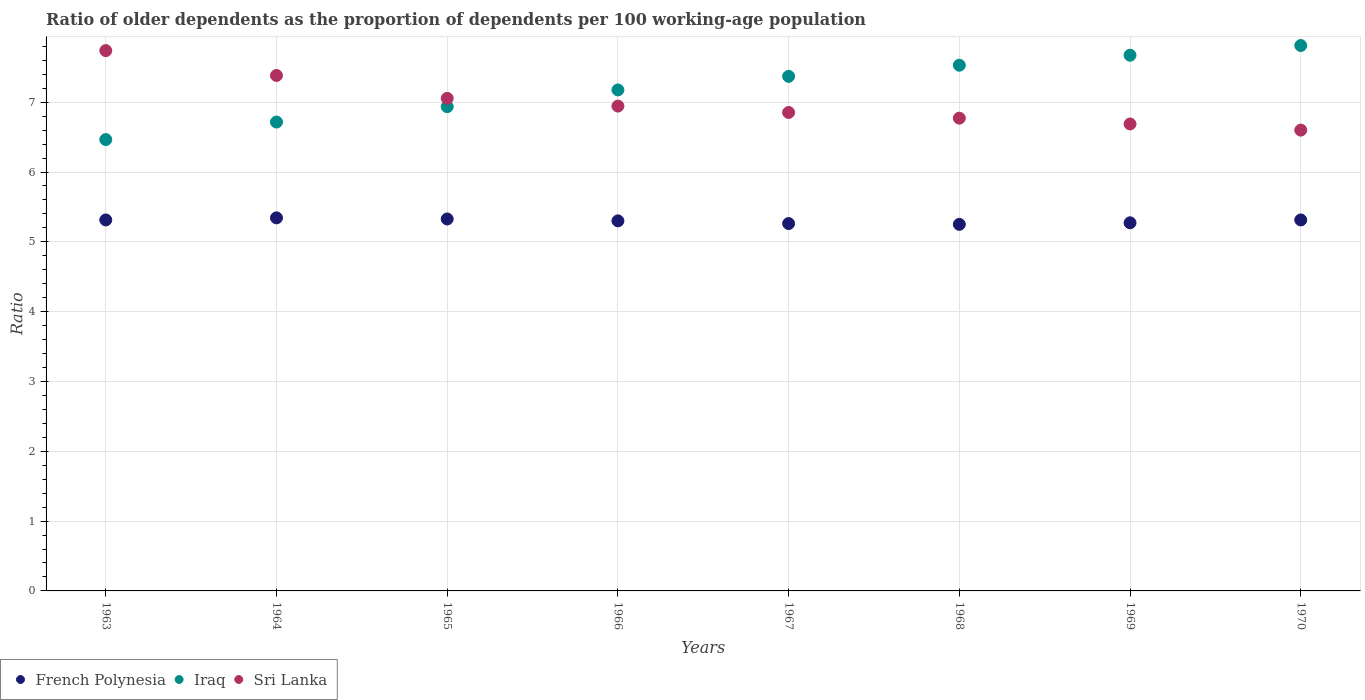Is the number of dotlines equal to the number of legend labels?
Offer a very short reply. Yes. What is the age dependency ratio(old) in Sri Lanka in 1970?
Ensure brevity in your answer.  6.6. Across all years, what is the maximum age dependency ratio(old) in Iraq?
Give a very brief answer. 7.81. Across all years, what is the minimum age dependency ratio(old) in Iraq?
Offer a very short reply. 6.46. In which year was the age dependency ratio(old) in Iraq maximum?
Your response must be concise. 1970. In which year was the age dependency ratio(old) in French Polynesia minimum?
Keep it short and to the point. 1968. What is the total age dependency ratio(old) in French Polynesia in the graph?
Your answer should be very brief. 42.38. What is the difference between the age dependency ratio(old) in French Polynesia in 1963 and that in 1964?
Your answer should be compact. -0.03. What is the difference between the age dependency ratio(old) in Iraq in 1967 and the age dependency ratio(old) in French Polynesia in 1964?
Provide a short and direct response. 2.03. What is the average age dependency ratio(old) in Iraq per year?
Your response must be concise. 7.21. In the year 1969, what is the difference between the age dependency ratio(old) in Sri Lanka and age dependency ratio(old) in Iraq?
Offer a very short reply. -0.98. In how many years, is the age dependency ratio(old) in Sri Lanka greater than 6.6?
Your response must be concise. 8. What is the ratio of the age dependency ratio(old) in Sri Lanka in 1963 to that in 1969?
Offer a very short reply. 1.16. Is the difference between the age dependency ratio(old) in Sri Lanka in 1963 and 1965 greater than the difference between the age dependency ratio(old) in Iraq in 1963 and 1965?
Ensure brevity in your answer.  Yes. What is the difference between the highest and the second highest age dependency ratio(old) in French Polynesia?
Give a very brief answer. 0.02. What is the difference between the highest and the lowest age dependency ratio(old) in Sri Lanka?
Give a very brief answer. 1.14. Is the age dependency ratio(old) in French Polynesia strictly greater than the age dependency ratio(old) in Sri Lanka over the years?
Provide a short and direct response. No. Is the age dependency ratio(old) in Sri Lanka strictly less than the age dependency ratio(old) in Iraq over the years?
Make the answer very short. No. Does the graph contain any zero values?
Your answer should be compact. No. Where does the legend appear in the graph?
Provide a short and direct response. Bottom left. How many legend labels are there?
Your answer should be compact. 3. What is the title of the graph?
Keep it short and to the point. Ratio of older dependents as the proportion of dependents per 100 working-age population. Does "Gambia, The" appear as one of the legend labels in the graph?
Keep it short and to the point. No. What is the label or title of the X-axis?
Ensure brevity in your answer.  Years. What is the label or title of the Y-axis?
Ensure brevity in your answer.  Ratio. What is the Ratio of French Polynesia in 1963?
Keep it short and to the point. 5.31. What is the Ratio in Iraq in 1963?
Offer a very short reply. 6.46. What is the Ratio in Sri Lanka in 1963?
Your response must be concise. 7.74. What is the Ratio in French Polynesia in 1964?
Offer a terse response. 5.34. What is the Ratio of Iraq in 1964?
Offer a terse response. 6.72. What is the Ratio of Sri Lanka in 1964?
Make the answer very short. 7.38. What is the Ratio in French Polynesia in 1965?
Provide a short and direct response. 5.33. What is the Ratio in Iraq in 1965?
Give a very brief answer. 6.94. What is the Ratio of Sri Lanka in 1965?
Provide a short and direct response. 7.05. What is the Ratio of French Polynesia in 1966?
Ensure brevity in your answer.  5.3. What is the Ratio in Iraq in 1966?
Your answer should be compact. 7.18. What is the Ratio of Sri Lanka in 1966?
Your answer should be compact. 6.94. What is the Ratio in French Polynesia in 1967?
Your response must be concise. 5.26. What is the Ratio in Iraq in 1967?
Your answer should be compact. 7.37. What is the Ratio in Sri Lanka in 1967?
Make the answer very short. 6.85. What is the Ratio in French Polynesia in 1968?
Give a very brief answer. 5.25. What is the Ratio in Iraq in 1968?
Keep it short and to the point. 7.53. What is the Ratio in Sri Lanka in 1968?
Give a very brief answer. 6.77. What is the Ratio of French Polynesia in 1969?
Offer a very short reply. 5.27. What is the Ratio of Iraq in 1969?
Make the answer very short. 7.67. What is the Ratio of Sri Lanka in 1969?
Your answer should be compact. 6.69. What is the Ratio in French Polynesia in 1970?
Ensure brevity in your answer.  5.31. What is the Ratio in Iraq in 1970?
Ensure brevity in your answer.  7.81. What is the Ratio of Sri Lanka in 1970?
Offer a terse response. 6.6. Across all years, what is the maximum Ratio of French Polynesia?
Your response must be concise. 5.34. Across all years, what is the maximum Ratio in Iraq?
Provide a short and direct response. 7.81. Across all years, what is the maximum Ratio in Sri Lanka?
Ensure brevity in your answer.  7.74. Across all years, what is the minimum Ratio in French Polynesia?
Provide a succinct answer. 5.25. Across all years, what is the minimum Ratio in Iraq?
Make the answer very short. 6.46. Across all years, what is the minimum Ratio of Sri Lanka?
Offer a very short reply. 6.6. What is the total Ratio in French Polynesia in the graph?
Offer a terse response. 42.38. What is the total Ratio in Iraq in the graph?
Your response must be concise. 57.68. What is the total Ratio in Sri Lanka in the graph?
Make the answer very short. 56.03. What is the difference between the Ratio in French Polynesia in 1963 and that in 1964?
Give a very brief answer. -0.03. What is the difference between the Ratio in Iraq in 1963 and that in 1964?
Your answer should be compact. -0.25. What is the difference between the Ratio in Sri Lanka in 1963 and that in 1964?
Offer a terse response. 0.36. What is the difference between the Ratio of French Polynesia in 1963 and that in 1965?
Provide a succinct answer. -0.01. What is the difference between the Ratio of Iraq in 1963 and that in 1965?
Ensure brevity in your answer.  -0.47. What is the difference between the Ratio in Sri Lanka in 1963 and that in 1965?
Offer a very short reply. 0.68. What is the difference between the Ratio in French Polynesia in 1963 and that in 1966?
Offer a very short reply. 0.01. What is the difference between the Ratio of Iraq in 1963 and that in 1966?
Provide a short and direct response. -0.71. What is the difference between the Ratio of Sri Lanka in 1963 and that in 1966?
Provide a succinct answer. 0.79. What is the difference between the Ratio in French Polynesia in 1963 and that in 1967?
Offer a terse response. 0.05. What is the difference between the Ratio in Iraq in 1963 and that in 1967?
Provide a short and direct response. -0.91. What is the difference between the Ratio of Sri Lanka in 1963 and that in 1967?
Your answer should be very brief. 0.89. What is the difference between the Ratio of French Polynesia in 1963 and that in 1968?
Ensure brevity in your answer.  0.06. What is the difference between the Ratio of Iraq in 1963 and that in 1968?
Make the answer very short. -1.07. What is the difference between the Ratio of Sri Lanka in 1963 and that in 1968?
Your response must be concise. 0.97. What is the difference between the Ratio of French Polynesia in 1963 and that in 1969?
Offer a terse response. 0.04. What is the difference between the Ratio in Iraq in 1963 and that in 1969?
Keep it short and to the point. -1.21. What is the difference between the Ratio in Sri Lanka in 1963 and that in 1969?
Your response must be concise. 1.05. What is the difference between the Ratio of Iraq in 1963 and that in 1970?
Offer a terse response. -1.35. What is the difference between the Ratio in Sri Lanka in 1963 and that in 1970?
Your answer should be very brief. 1.14. What is the difference between the Ratio of French Polynesia in 1964 and that in 1965?
Make the answer very short. 0.02. What is the difference between the Ratio in Iraq in 1964 and that in 1965?
Keep it short and to the point. -0.22. What is the difference between the Ratio of Sri Lanka in 1964 and that in 1965?
Keep it short and to the point. 0.33. What is the difference between the Ratio of French Polynesia in 1964 and that in 1966?
Your answer should be compact. 0.04. What is the difference between the Ratio in Iraq in 1964 and that in 1966?
Offer a very short reply. -0.46. What is the difference between the Ratio of Sri Lanka in 1964 and that in 1966?
Provide a succinct answer. 0.44. What is the difference between the Ratio in French Polynesia in 1964 and that in 1967?
Offer a terse response. 0.08. What is the difference between the Ratio of Iraq in 1964 and that in 1967?
Provide a short and direct response. -0.65. What is the difference between the Ratio in Sri Lanka in 1964 and that in 1967?
Your answer should be compact. 0.53. What is the difference between the Ratio in French Polynesia in 1964 and that in 1968?
Offer a very short reply. 0.09. What is the difference between the Ratio in Iraq in 1964 and that in 1968?
Your answer should be compact. -0.81. What is the difference between the Ratio of Sri Lanka in 1964 and that in 1968?
Offer a very short reply. 0.61. What is the difference between the Ratio of French Polynesia in 1964 and that in 1969?
Make the answer very short. 0.07. What is the difference between the Ratio of Iraq in 1964 and that in 1969?
Provide a succinct answer. -0.96. What is the difference between the Ratio in Sri Lanka in 1964 and that in 1969?
Offer a very short reply. 0.69. What is the difference between the Ratio in French Polynesia in 1964 and that in 1970?
Offer a terse response. 0.03. What is the difference between the Ratio in Iraq in 1964 and that in 1970?
Offer a very short reply. -1.1. What is the difference between the Ratio in Sri Lanka in 1964 and that in 1970?
Give a very brief answer. 0.78. What is the difference between the Ratio in French Polynesia in 1965 and that in 1966?
Provide a succinct answer. 0.03. What is the difference between the Ratio in Iraq in 1965 and that in 1966?
Provide a short and direct response. -0.24. What is the difference between the Ratio in Sri Lanka in 1965 and that in 1966?
Ensure brevity in your answer.  0.11. What is the difference between the Ratio of French Polynesia in 1965 and that in 1967?
Your answer should be very brief. 0.07. What is the difference between the Ratio of Iraq in 1965 and that in 1967?
Keep it short and to the point. -0.43. What is the difference between the Ratio in Sri Lanka in 1965 and that in 1967?
Make the answer very short. 0.2. What is the difference between the Ratio of French Polynesia in 1965 and that in 1968?
Ensure brevity in your answer.  0.08. What is the difference between the Ratio of Iraq in 1965 and that in 1968?
Keep it short and to the point. -0.59. What is the difference between the Ratio of Sri Lanka in 1965 and that in 1968?
Ensure brevity in your answer.  0.28. What is the difference between the Ratio in French Polynesia in 1965 and that in 1969?
Keep it short and to the point. 0.05. What is the difference between the Ratio of Iraq in 1965 and that in 1969?
Ensure brevity in your answer.  -0.74. What is the difference between the Ratio of Sri Lanka in 1965 and that in 1969?
Your answer should be compact. 0.37. What is the difference between the Ratio of French Polynesia in 1965 and that in 1970?
Provide a succinct answer. 0.01. What is the difference between the Ratio of Iraq in 1965 and that in 1970?
Offer a terse response. -0.88. What is the difference between the Ratio in Sri Lanka in 1965 and that in 1970?
Provide a succinct answer. 0.45. What is the difference between the Ratio in French Polynesia in 1966 and that in 1967?
Your answer should be compact. 0.04. What is the difference between the Ratio in Iraq in 1966 and that in 1967?
Ensure brevity in your answer.  -0.19. What is the difference between the Ratio in Sri Lanka in 1966 and that in 1967?
Your answer should be very brief. 0.09. What is the difference between the Ratio of French Polynesia in 1966 and that in 1968?
Your response must be concise. 0.05. What is the difference between the Ratio of Iraq in 1966 and that in 1968?
Offer a very short reply. -0.35. What is the difference between the Ratio in Sri Lanka in 1966 and that in 1968?
Offer a very short reply. 0.17. What is the difference between the Ratio of French Polynesia in 1966 and that in 1969?
Offer a terse response. 0.03. What is the difference between the Ratio of Iraq in 1966 and that in 1969?
Keep it short and to the point. -0.5. What is the difference between the Ratio of Sri Lanka in 1966 and that in 1969?
Your response must be concise. 0.26. What is the difference between the Ratio in French Polynesia in 1966 and that in 1970?
Offer a very short reply. -0.01. What is the difference between the Ratio of Iraq in 1966 and that in 1970?
Your response must be concise. -0.64. What is the difference between the Ratio of Sri Lanka in 1966 and that in 1970?
Offer a terse response. 0.34. What is the difference between the Ratio of French Polynesia in 1967 and that in 1968?
Your answer should be compact. 0.01. What is the difference between the Ratio of Iraq in 1967 and that in 1968?
Give a very brief answer. -0.16. What is the difference between the Ratio in Sri Lanka in 1967 and that in 1968?
Offer a very short reply. 0.08. What is the difference between the Ratio of French Polynesia in 1967 and that in 1969?
Make the answer very short. -0.01. What is the difference between the Ratio of Iraq in 1967 and that in 1969?
Provide a succinct answer. -0.3. What is the difference between the Ratio of Sri Lanka in 1967 and that in 1969?
Offer a terse response. 0.16. What is the difference between the Ratio in French Polynesia in 1967 and that in 1970?
Keep it short and to the point. -0.05. What is the difference between the Ratio of Iraq in 1967 and that in 1970?
Provide a short and direct response. -0.44. What is the difference between the Ratio in Sri Lanka in 1967 and that in 1970?
Your answer should be compact. 0.25. What is the difference between the Ratio in French Polynesia in 1968 and that in 1969?
Make the answer very short. -0.02. What is the difference between the Ratio of Iraq in 1968 and that in 1969?
Ensure brevity in your answer.  -0.14. What is the difference between the Ratio of Sri Lanka in 1968 and that in 1969?
Ensure brevity in your answer.  0.08. What is the difference between the Ratio of French Polynesia in 1968 and that in 1970?
Your answer should be very brief. -0.06. What is the difference between the Ratio of Iraq in 1968 and that in 1970?
Provide a succinct answer. -0.28. What is the difference between the Ratio in Sri Lanka in 1968 and that in 1970?
Ensure brevity in your answer.  0.17. What is the difference between the Ratio of French Polynesia in 1969 and that in 1970?
Offer a very short reply. -0.04. What is the difference between the Ratio in Iraq in 1969 and that in 1970?
Keep it short and to the point. -0.14. What is the difference between the Ratio in Sri Lanka in 1969 and that in 1970?
Make the answer very short. 0.09. What is the difference between the Ratio in French Polynesia in 1963 and the Ratio in Iraq in 1964?
Ensure brevity in your answer.  -1.4. What is the difference between the Ratio in French Polynesia in 1963 and the Ratio in Sri Lanka in 1964?
Offer a very short reply. -2.07. What is the difference between the Ratio of Iraq in 1963 and the Ratio of Sri Lanka in 1964?
Keep it short and to the point. -0.92. What is the difference between the Ratio of French Polynesia in 1963 and the Ratio of Iraq in 1965?
Offer a very short reply. -1.62. What is the difference between the Ratio of French Polynesia in 1963 and the Ratio of Sri Lanka in 1965?
Provide a short and direct response. -1.74. What is the difference between the Ratio of Iraq in 1963 and the Ratio of Sri Lanka in 1965?
Keep it short and to the point. -0.59. What is the difference between the Ratio of French Polynesia in 1963 and the Ratio of Iraq in 1966?
Keep it short and to the point. -1.86. What is the difference between the Ratio of French Polynesia in 1963 and the Ratio of Sri Lanka in 1966?
Provide a short and direct response. -1.63. What is the difference between the Ratio of Iraq in 1963 and the Ratio of Sri Lanka in 1966?
Your answer should be very brief. -0.48. What is the difference between the Ratio of French Polynesia in 1963 and the Ratio of Iraq in 1967?
Make the answer very short. -2.06. What is the difference between the Ratio of French Polynesia in 1963 and the Ratio of Sri Lanka in 1967?
Ensure brevity in your answer.  -1.54. What is the difference between the Ratio in Iraq in 1963 and the Ratio in Sri Lanka in 1967?
Ensure brevity in your answer.  -0.39. What is the difference between the Ratio in French Polynesia in 1963 and the Ratio in Iraq in 1968?
Offer a very short reply. -2.22. What is the difference between the Ratio of French Polynesia in 1963 and the Ratio of Sri Lanka in 1968?
Your answer should be very brief. -1.46. What is the difference between the Ratio of Iraq in 1963 and the Ratio of Sri Lanka in 1968?
Ensure brevity in your answer.  -0.31. What is the difference between the Ratio in French Polynesia in 1963 and the Ratio in Iraq in 1969?
Make the answer very short. -2.36. What is the difference between the Ratio of French Polynesia in 1963 and the Ratio of Sri Lanka in 1969?
Offer a very short reply. -1.37. What is the difference between the Ratio of Iraq in 1963 and the Ratio of Sri Lanka in 1969?
Offer a very short reply. -0.22. What is the difference between the Ratio in French Polynesia in 1963 and the Ratio in Iraq in 1970?
Provide a succinct answer. -2.5. What is the difference between the Ratio of French Polynesia in 1963 and the Ratio of Sri Lanka in 1970?
Ensure brevity in your answer.  -1.29. What is the difference between the Ratio in Iraq in 1963 and the Ratio in Sri Lanka in 1970?
Your answer should be compact. -0.14. What is the difference between the Ratio in French Polynesia in 1964 and the Ratio in Iraq in 1965?
Provide a short and direct response. -1.59. What is the difference between the Ratio of French Polynesia in 1964 and the Ratio of Sri Lanka in 1965?
Your response must be concise. -1.71. What is the difference between the Ratio in Iraq in 1964 and the Ratio in Sri Lanka in 1965?
Provide a short and direct response. -0.34. What is the difference between the Ratio in French Polynesia in 1964 and the Ratio in Iraq in 1966?
Ensure brevity in your answer.  -1.83. What is the difference between the Ratio in French Polynesia in 1964 and the Ratio in Sri Lanka in 1966?
Your answer should be compact. -1.6. What is the difference between the Ratio in Iraq in 1964 and the Ratio in Sri Lanka in 1966?
Your answer should be compact. -0.23. What is the difference between the Ratio in French Polynesia in 1964 and the Ratio in Iraq in 1967?
Keep it short and to the point. -2.03. What is the difference between the Ratio of French Polynesia in 1964 and the Ratio of Sri Lanka in 1967?
Provide a short and direct response. -1.51. What is the difference between the Ratio in Iraq in 1964 and the Ratio in Sri Lanka in 1967?
Offer a terse response. -0.14. What is the difference between the Ratio in French Polynesia in 1964 and the Ratio in Iraq in 1968?
Make the answer very short. -2.19. What is the difference between the Ratio in French Polynesia in 1964 and the Ratio in Sri Lanka in 1968?
Provide a succinct answer. -1.43. What is the difference between the Ratio of Iraq in 1964 and the Ratio of Sri Lanka in 1968?
Your answer should be compact. -0.06. What is the difference between the Ratio in French Polynesia in 1964 and the Ratio in Iraq in 1969?
Make the answer very short. -2.33. What is the difference between the Ratio of French Polynesia in 1964 and the Ratio of Sri Lanka in 1969?
Ensure brevity in your answer.  -1.34. What is the difference between the Ratio of Iraq in 1964 and the Ratio of Sri Lanka in 1969?
Your response must be concise. 0.03. What is the difference between the Ratio of French Polynesia in 1964 and the Ratio of Iraq in 1970?
Offer a very short reply. -2.47. What is the difference between the Ratio of French Polynesia in 1964 and the Ratio of Sri Lanka in 1970?
Make the answer very short. -1.26. What is the difference between the Ratio of Iraq in 1964 and the Ratio of Sri Lanka in 1970?
Keep it short and to the point. 0.12. What is the difference between the Ratio in French Polynesia in 1965 and the Ratio in Iraq in 1966?
Provide a short and direct response. -1.85. What is the difference between the Ratio in French Polynesia in 1965 and the Ratio in Sri Lanka in 1966?
Your answer should be very brief. -1.62. What is the difference between the Ratio of Iraq in 1965 and the Ratio of Sri Lanka in 1966?
Make the answer very short. -0.01. What is the difference between the Ratio of French Polynesia in 1965 and the Ratio of Iraq in 1967?
Your answer should be compact. -2.04. What is the difference between the Ratio of French Polynesia in 1965 and the Ratio of Sri Lanka in 1967?
Your answer should be very brief. -1.53. What is the difference between the Ratio in Iraq in 1965 and the Ratio in Sri Lanka in 1967?
Your answer should be compact. 0.08. What is the difference between the Ratio in French Polynesia in 1965 and the Ratio in Iraq in 1968?
Provide a short and direct response. -2.2. What is the difference between the Ratio of French Polynesia in 1965 and the Ratio of Sri Lanka in 1968?
Offer a very short reply. -1.44. What is the difference between the Ratio of Iraq in 1965 and the Ratio of Sri Lanka in 1968?
Your answer should be very brief. 0.16. What is the difference between the Ratio of French Polynesia in 1965 and the Ratio of Iraq in 1969?
Make the answer very short. -2.35. What is the difference between the Ratio in French Polynesia in 1965 and the Ratio in Sri Lanka in 1969?
Offer a terse response. -1.36. What is the difference between the Ratio of Iraq in 1965 and the Ratio of Sri Lanka in 1969?
Make the answer very short. 0.25. What is the difference between the Ratio of French Polynesia in 1965 and the Ratio of Iraq in 1970?
Keep it short and to the point. -2.48. What is the difference between the Ratio in French Polynesia in 1965 and the Ratio in Sri Lanka in 1970?
Give a very brief answer. -1.27. What is the difference between the Ratio in Iraq in 1965 and the Ratio in Sri Lanka in 1970?
Ensure brevity in your answer.  0.34. What is the difference between the Ratio in French Polynesia in 1966 and the Ratio in Iraq in 1967?
Provide a short and direct response. -2.07. What is the difference between the Ratio in French Polynesia in 1966 and the Ratio in Sri Lanka in 1967?
Ensure brevity in your answer.  -1.55. What is the difference between the Ratio in Iraq in 1966 and the Ratio in Sri Lanka in 1967?
Give a very brief answer. 0.32. What is the difference between the Ratio of French Polynesia in 1966 and the Ratio of Iraq in 1968?
Offer a very short reply. -2.23. What is the difference between the Ratio in French Polynesia in 1966 and the Ratio in Sri Lanka in 1968?
Make the answer very short. -1.47. What is the difference between the Ratio of Iraq in 1966 and the Ratio of Sri Lanka in 1968?
Make the answer very short. 0.4. What is the difference between the Ratio of French Polynesia in 1966 and the Ratio of Iraq in 1969?
Make the answer very short. -2.37. What is the difference between the Ratio of French Polynesia in 1966 and the Ratio of Sri Lanka in 1969?
Give a very brief answer. -1.39. What is the difference between the Ratio of Iraq in 1966 and the Ratio of Sri Lanka in 1969?
Your response must be concise. 0.49. What is the difference between the Ratio in French Polynesia in 1966 and the Ratio in Iraq in 1970?
Make the answer very short. -2.51. What is the difference between the Ratio in French Polynesia in 1966 and the Ratio in Sri Lanka in 1970?
Give a very brief answer. -1.3. What is the difference between the Ratio of Iraq in 1966 and the Ratio of Sri Lanka in 1970?
Make the answer very short. 0.58. What is the difference between the Ratio of French Polynesia in 1967 and the Ratio of Iraq in 1968?
Keep it short and to the point. -2.27. What is the difference between the Ratio of French Polynesia in 1967 and the Ratio of Sri Lanka in 1968?
Give a very brief answer. -1.51. What is the difference between the Ratio of Iraq in 1967 and the Ratio of Sri Lanka in 1968?
Offer a terse response. 0.6. What is the difference between the Ratio of French Polynesia in 1967 and the Ratio of Iraq in 1969?
Your answer should be compact. -2.41. What is the difference between the Ratio in French Polynesia in 1967 and the Ratio in Sri Lanka in 1969?
Offer a terse response. -1.43. What is the difference between the Ratio in Iraq in 1967 and the Ratio in Sri Lanka in 1969?
Give a very brief answer. 0.68. What is the difference between the Ratio in French Polynesia in 1967 and the Ratio in Iraq in 1970?
Make the answer very short. -2.55. What is the difference between the Ratio in French Polynesia in 1967 and the Ratio in Sri Lanka in 1970?
Keep it short and to the point. -1.34. What is the difference between the Ratio of Iraq in 1967 and the Ratio of Sri Lanka in 1970?
Ensure brevity in your answer.  0.77. What is the difference between the Ratio of French Polynesia in 1968 and the Ratio of Iraq in 1969?
Provide a succinct answer. -2.42. What is the difference between the Ratio in French Polynesia in 1968 and the Ratio in Sri Lanka in 1969?
Give a very brief answer. -1.44. What is the difference between the Ratio in Iraq in 1968 and the Ratio in Sri Lanka in 1969?
Offer a very short reply. 0.84. What is the difference between the Ratio of French Polynesia in 1968 and the Ratio of Iraq in 1970?
Make the answer very short. -2.56. What is the difference between the Ratio in French Polynesia in 1968 and the Ratio in Sri Lanka in 1970?
Ensure brevity in your answer.  -1.35. What is the difference between the Ratio in Iraq in 1968 and the Ratio in Sri Lanka in 1970?
Keep it short and to the point. 0.93. What is the difference between the Ratio of French Polynesia in 1969 and the Ratio of Iraq in 1970?
Offer a terse response. -2.54. What is the difference between the Ratio in French Polynesia in 1969 and the Ratio in Sri Lanka in 1970?
Offer a terse response. -1.33. What is the difference between the Ratio of Iraq in 1969 and the Ratio of Sri Lanka in 1970?
Give a very brief answer. 1.07. What is the average Ratio of French Polynesia per year?
Offer a terse response. 5.3. What is the average Ratio of Iraq per year?
Offer a very short reply. 7.21. What is the average Ratio in Sri Lanka per year?
Provide a short and direct response. 7. In the year 1963, what is the difference between the Ratio in French Polynesia and Ratio in Iraq?
Your answer should be very brief. -1.15. In the year 1963, what is the difference between the Ratio of French Polynesia and Ratio of Sri Lanka?
Your answer should be very brief. -2.43. In the year 1963, what is the difference between the Ratio of Iraq and Ratio of Sri Lanka?
Offer a terse response. -1.27. In the year 1964, what is the difference between the Ratio in French Polynesia and Ratio in Iraq?
Give a very brief answer. -1.37. In the year 1964, what is the difference between the Ratio of French Polynesia and Ratio of Sri Lanka?
Give a very brief answer. -2.04. In the year 1964, what is the difference between the Ratio of Iraq and Ratio of Sri Lanka?
Offer a terse response. -0.67. In the year 1965, what is the difference between the Ratio in French Polynesia and Ratio in Iraq?
Make the answer very short. -1.61. In the year 1965, what is the difference between the Ratio of French Polynesia and Ratio of Sri Lanka?
Your response must be concise. -1.73. In the year 1965, what is the difference between the Ratio of Iraq and Ratio of Sri Lanka?
Keep it short and to the point. -0.12. In the year 1966, what is the difference between the Ratio of French Polynesia and Ratio of Iraq?
Your response must be concise. -1.88. In the year 1966, what is the difference between the Ratio in French Polynesia and Ratio in Sri Lanka?
Offer a terse response. -1.64. In the year 1966, what is the difference between the Ratio of Iraq and Ratio of Sri Lanka?
Offer a very short reply. 0.23. In the year 1967, what is the difference between the Ratio in French Polynesia and Ratio in Iraq?
Your answer should be compact. -2.11. In the year 1967, what is the difference between the Ratio of French Polynesia and Ratio of Sri Lanka?
Your response must be concise. -1.59. In the year 1967, what is the difference between the Ratio in Iraq and Ratio in Sri Lanka?
Give a very brief answer. 0.52. In the year 1968, what is the difference between the Ratio in French Polynesia and Ratio in Iraq?
Provide a succinct answer. -2.28. In the year 1968, what is the difference between the Ratio of French Polynesia and Ratio of Sri Lanka?
Give a very brief answer. -1.52. In the year 1968, what is the difference between the Ratio in Iraq and Ratio in Sri Lanka?
Offer a very short reply. 0.76. In the year 1969, what is the difference between the Ratio of French Polynesia and Ratio of Iraq?
Your answer should be very brief. -2.4. In the year 1969, what is the difference between the Ratio in French Polynesia and Ratio in Sri Lanka?
Your answer should be very brief. -1.42. In the year 1970, what is the difference between the Ratio of French Polynesia and Ratio of Iraq?
Your response must be concise. -2.5. In the year 1970, what is the difference between the Ratio in French Polynesia and Ratio in Sri Lanka?
Provide a short and direct response. -1.29. In the year 1970, what is the difference between the Ratio in Iraq and Ratio in Sri Lanka?
Provide a succinct answer. 1.21. What is the ratio of the Ratio in French Polynesia in 1963 to that in 1964?
Your response must be concise. 0.99. What is the ratio of the Ratio in Iraq in 1963 to that in 1964?
Your answer should be compact. 0.96. What is the ratio of the Ratio of Sri Lanka in 1963 to that in 1964?
Provide a succinct answer. 1.05. What is the ratio of the Ratio of French Polynesia in 1963 to that in 1965?
Your response must be concise. 1. What is the ratio of the Ratio of Iraq in 1963 to that in 1965?
Offer a very short reply. 0.93. What is the ratio of the Ratio of Sri Lanka in 1963 to that in 1965?
Give a very brief answer. 1.1. What is the ratio of the Ratio of French Polynesia in 1963 to that in 1966?
Your answer should be very brief. 1. What is the ratio of the Ratio of Iraq in 1963 to that in 1966?
Provide a succinct answer. 0.9. What is the ratio of the Ratio of Sri Lanka in 1963 to that in 1966?
Your response must be concise. 1.11. What is the ratio of the Ratio in French Polynesia in 1963 to that in 1967?
Provide a succinct answer. 1.01. What is the ratio of the Ratio in Iraq in 1963 to that in 1967?
Provide a short and direct response. 0.88. What is the ratio of the Ratio in Sri Lanka in 1963 to that in 1967?
Provide a short and direct response. 1.13. What is the ratio of the Ratio of French Polynesia in 1963 to that in 1968?
Give a very brief answer. 1.01. What is the ratio of the Ratio in Iraq in 1963 to that in 1968?
Your response must be concise. 0.86. What is the ratio of the Ratio of Sri Lanka in 1963 to that in 1968?
Make the answer very short. 1.14. What is the ratio of the Ratio of French Polynesia in 1963 to that in 1969?
Give a very brief answer. 1.01. What is the ratio of the Ratio of Iraq in 1963 to that in 1969?
Your answer should be compact. 0.84. What is the ratio of the Ratio of Sri Lanka in 1963 to that in 1969?
Keep it short and to the point. 1.16. What is the ratio of the Ratio of French Polynesia in 1963 to that in 1970?
Offer a terse response. 1. What is the ratio of the Ratio in Iraq in 1963 to that in 1970?
Provide a succinct answer. 0.83. What is the ratio of the Ratio in Sri Lanka in 1963 to that in 1970?
Provide a short and direct response. 1.17. What is the ratio of the Ratio in Iraq in 1964 to that in 1965?
Provide a short and direct response. 0.97. What is the ratio of the Ratio in Sri Lanka in 1964 to that in 1965?
Give a very brief answer. 1.05. What is the ratio of the Ratio in Iraq in 1964 to that in 1966?
Your answer should be very brief. 0.94. What is the ratio of the Ratio in Sri Lanka in 1964 to that in 1966?
Offer a terse response. 1.06. What is the ratio of the Ratio of French Polynesia in 1964 to that in 1967?
Provide a short and direct response. 1.02. What is the ratio of the Ratio in Iraq in 1964 to that in 1967?
Offer a terse response. 0.91. What is the ratio of the Ratio of Sri Lanka in 1964 to that in 1967?
Your response must be concise. 1.08. What is the ratio of the Ratio in French Polynesia in 1964 to that in 1968?
Ensure brevity in your answer.  1.02. What is the ratio of the Ratio in Iraq in 1964 to that in 1968?
Keep it short and to the point. 0.89. What is the ratio of the Ratio of Sri Lanka in 1964 to that in 1968?
Keep it short and to the point. 1.09. What is the ratio of the Ratio in French Polynesia in 1964 to that in 1969?
Keep it short and to the point. 1.01. What is the ratio of the Ratio in Iraq in 1964 to that in 1969?
Your answer should be compact. 0.88. What is the ratio of the Ratio in Sri Lanka in 1964 to that in 1969?
Your response must be concise. 1.1. What is the ratio of the Ratio in French Polynesia in 1964 to that in 1970?
Make the answer very short. 1.01. What is the ratio of the Ratio in Iraq in 1964 to that in 1970?
Provide a short and direct response. 0.86. What is the ratio of the Ratio in Sri Lanka in 1964 to that in 1970?
Offer a terse response. 1.12. What is the ratio of the Ratio in French Polynesia in 1965 to that in 1966?
Offer a terse response. 1. What is the ratio of the Ratio in Iraq in 1965 to that in 1966?
Your answer should be compact. 0.97. What is the ratio of the Ratio of Sri Lanka in 1965 to that in 1966?
Your response must be concise. 1.02. What is the ratio of the Ratio in French Polynesia in 1965 to that in 1967?
Provide a short and direct response. 1.01. What is the ratio of the Ratio in Iraq in 1965 to that in 1967?
Provide a succinct answer. 0.94. What is the ratio of the Ratio of Sri Lanka in 1965 to that in 1967?
Ensure brevity in your answer.  1.03. What is the ratio of the Ratio of French Polynesia in 1965 to that in 1968?
Ensure brevity in your answer.  1.01. What is the ratio of the Ratio of Iraq in 1965 to that in 1968?
Make the answer very short. 0.92. What is the ratio of the Ratio of Sri Lanka in 1965 to that in 1968?
Your answer should be very brief. 1.04. What is the ratio of the Ratio in French Polynesia in 1965 to that in 1969?
Offer a terse response. 1.01. What is the ratio of the Ratio in Iraq in 1965 to that in 1969?
Make the answer very short. 0.9. What is the ratio of the Ratio in Sri Lanka in 1965 to that in 1969?
Your answer should be compact. 1.05. What is the ratio of the Ratio of French Polynesia in 1965 to that in 1970?
Your response must be concise. 1. What is the ratio of the Ratio of Iraq in 1965 to that in 1970?
Keep it short and to the point. 0.89. What is the ratio of the Ratio of Sri Lanka in 1965 to that in 1970?
Ensure brevity in your answer.  1.07. What is the ratio of the Ratio in French Polynesia in 1966 to that in 1967?
Offer a very short reply. 1.01. What is the ratio of the Ratio of Iraq in 1966 to that in 1967?
Offer a terse response. 0.97. What is the ratio of the Ratio in Sri Lanka in 1966 to that in 1967?
Provide a short and direct response. 1.01. What is the ratio of the Ratio of French Polynesia in 1966 to that in 1968?
Ensure brevity in your answer.  1.01. What is the ratio of the Ratio of Iraq in 1966 to that in 1968?
Provide a short and direct response. 0.95. What is the ratio of the Ratio of Sri Lanka in 1966 to that in 1968?
Offer a terse response. 1.03. What is the ratio of the Ratio of French Polynesia in 1966 to that in 1969?
Your response must be concise. 1.01. What is the ratio of the Ratio in Iraq in 1966 to that in 1969?
Your answer should be very brief. 0.94. What is the ratio of the Ratio of Sri Lanka in 1966 to that in 1969?
Provide a short and direct response. 1.04. What is the ratio of the Ratio in French Polynesia in 1966 to that in 1970?
Your response must be concise. 1. What is the ratio of the Ratio in Iraq in 1966 to that in 1970?
Offer a terse response. 0.92. What is the ratio of the Ratio of Sri Lanka in 1966 to that in 1970?
Give a very brief answer. 1.05. What is the ratio of the Ratio in French Polynesia in 1967 to that in 1968?
Your response must be concise. 1. What is the ratio of the Ratio in Iraq in 1967 to that in 1968?
Your answer should be very brief. 0.98. What is the ratio of the Ratio of Sri Lanka in 1967 to that in 1968?
Provide a short and direct response. 1.01. What is the ratio of the Ratio in Iraq in 1967 to that in 1969?
Your answer should be very brief. 0.96. What is the ratio of the Ratio in Sri Lanka in 1967 to that in 1969?
Offer a terse response. 1.02. What is the ratio of the Ratio of French Polynesia in 1967 to that in 1970?
Provide a short and direct response. 0.99. What is the ratio of the Ratio in Iraq in 1967 to that in 1970?
Give a very brief answer. 0.94. What is the ratio of the Ratio in Sri Lanka in 1967 to that in 1970?
Ensure brevity in your answer.  1.04. What is the ratio of the Ratio of French Polynesia in 1968 to that in 1969?
Give a very brief answer. 1. What is the ratio of the Ratio in Iraq in 1968 to that in 1969?
Your response must be concise. 0.98. What is the ratio of the Ratio of Sri Lanka in 1968 to that in 1969?
Keep it short and to the point. 1.01. What is the ratio of the Ratio of French Polynesia in 1968 to that in 1970?
Your answer should be compact. 0.99. What is the ratio of the Ratio of Iraq in 1968 to that in 1970?
Make the answer very short. 0.96. What is the ratio of the Ratio of French Polynesia in 1969 to that in 1970?
Ensure brevity in your answer.  0.99. What is the ratio of the Ratio of Iraq in 1969 to that in 1970?
Offer a very short reply. 0.98. What is the ratio of the Ratio of Sri Lanka in 1969 to that in 1970?
Provide a succinct answer. 1.01. What is the difference between the highest and the second highest Ratio in French Polynesia?
Provide a short and direct response. 0.02. What is the difference between the highest and the second highest Ratio of Iraq?
Give a very brief answer. 0.14. What is the difference between the highest and the second highest Ratio of Sri Lanka?
Provide a short and direct response. 0.36. What is the difference between the highest and the lowest Ratio in French Polynesia?
Your answer should be compact. 0.09. What is the difference between the highest and the lowest Ratio of Iraq?
Ensure brevity in your answer.  1.35. What is the difference between the highest and the lowest Ratio in Sri Lanka?
Offer a terse response. 1.14. 